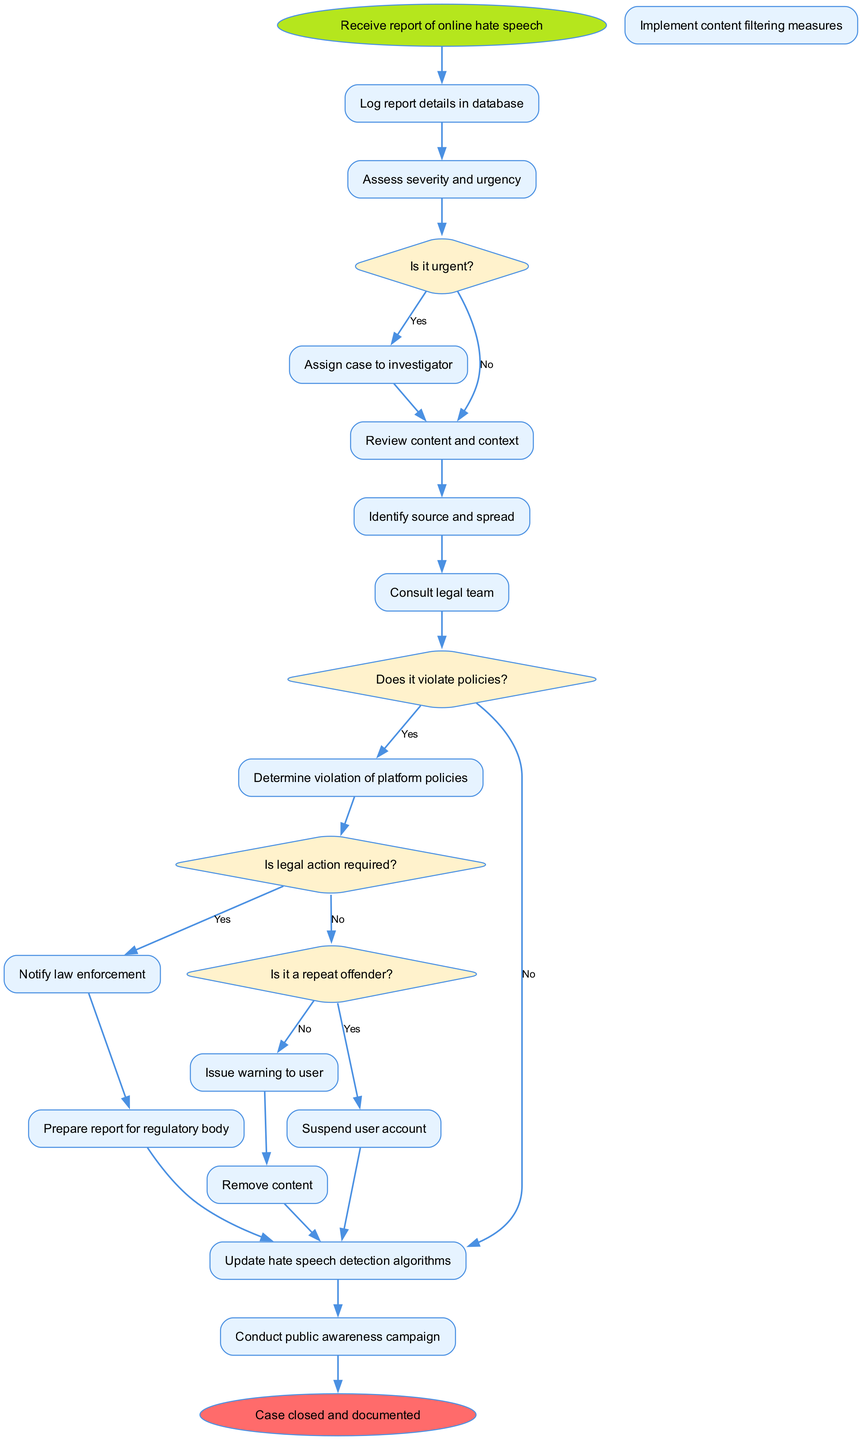What is the first activity in the workflow? The diagram starts with the 'Receive report of online hate speech' node. This is indicated as the starting point of the workflow, where the process begins.
Answer: Receive report of online hate speech How many activities are listed in the diagram? The diagram contains 15 distinct activities, as identified by counting the number of activities shown in the workflow section.
Answer: 15 What decision comes after assessing severity and urgency? Following 'Assess severity and urgency', the next decision node is 'Is it urgent?'. This is placed sequentially in the workflow after the assessment.
Answer: Is it urgent? If the report is not urgent, what activity follows? If the report is determined to be not urgent ('No' branch from 'Is it urgent?'), the next activity is to 'Review content and context', indicating the flow of the investigation process.
Answer: Review content and context What happens if the content does not violate platform policies? If it does not violate platform policies ('No' branch from 'Does it violate policies?'), the subsequent action is to 'Implement content filtering measures', showing that despite no policy violation, further preventive actions can be taken.
Answer: Implement content filtering measures How does legal consultation relate to the violation check? After consulting the legal team, the next decision involves checking if legal action is required ('Is legal action required?'). This emphasizes the connection between legal advice and determining the necessary regulatory action.
Answer: Is legal action required? What is the last activity before the case is closed? Before the case reaches its closure, the last activity is 'Conduct public awareness campaign', indicating an action aimed at informing the public about hate speech after all investigations are completed.
Answer: Conduct public awareness campaign What indicates that a user is a repeat offender? The decision 'Is it a repeat offender?' indicates whether previous offenses have been recorded, and it directly influences subsequent actions in the workflow.
Answer: Is it a repeat offender? 